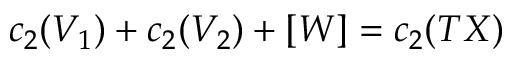Convert formula to latex. <formula><loc_0><loc_0><loc_500><loc_500>c _ { 2 } ( V _ { 1 } ) + c _ { 2 } ( V _ { 2 } ) + [ W ] = c _ { 2 } ( T X )</formula> 